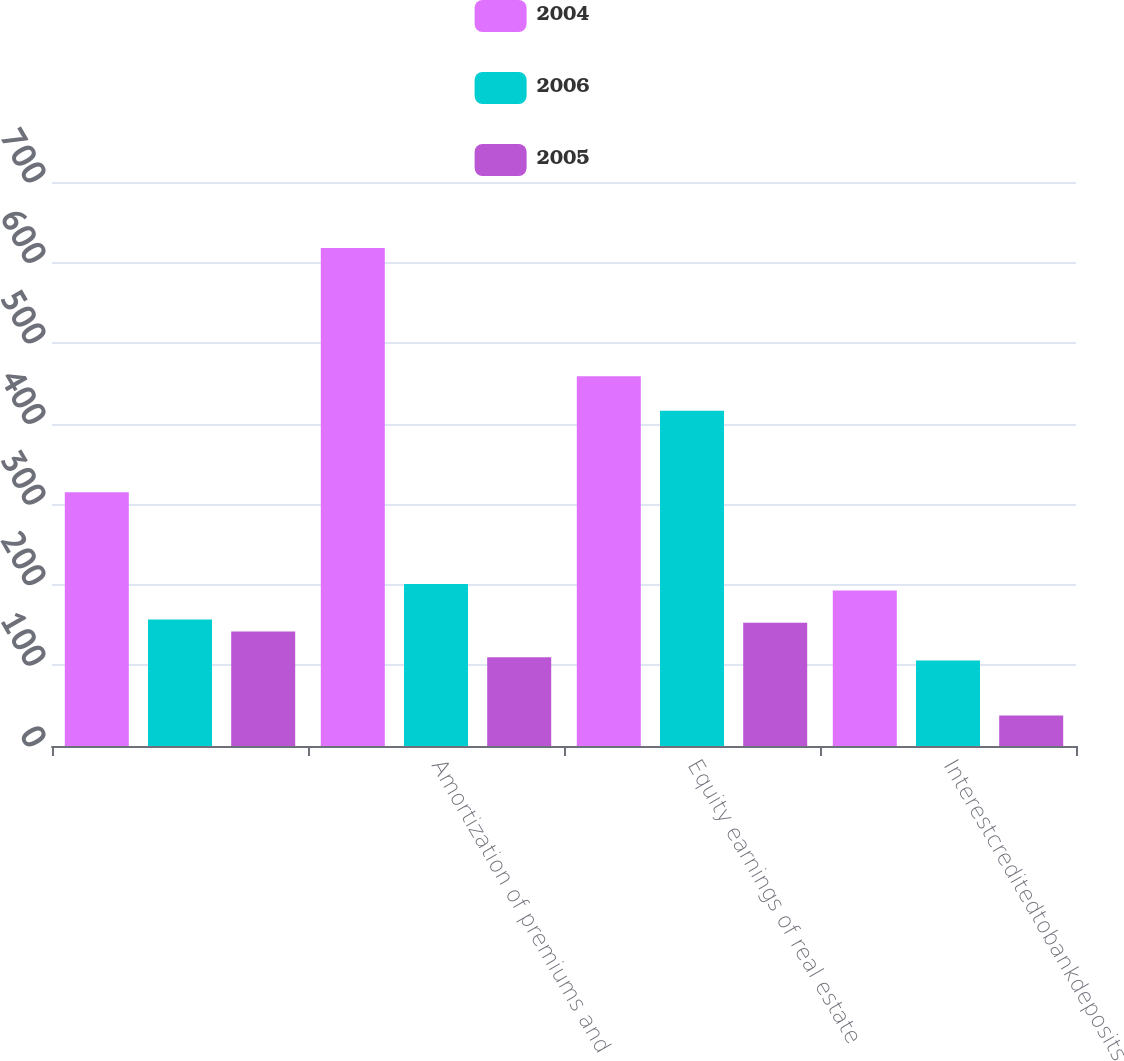Convert chart to OTSL. <chart><loc_0><loc_0><loc_500><loc_500><stacked_bar_chart><ecel><fcel>Unnamed: 1<fcel>Amortization of premiums and<fcel>Equity earnings of real estate<fcel>Interestcreditedtobankdeposits<nl><fcel>2004<fcel>315<fcel>618<fcel>459<fcel>193<nl><fcel>2006<fcel>157<fcel>201<fcel>416<fcel>106<nl><fcel>2005<fcel>142<fcel>110<fcel>153<fcel>38<nl></chart> 